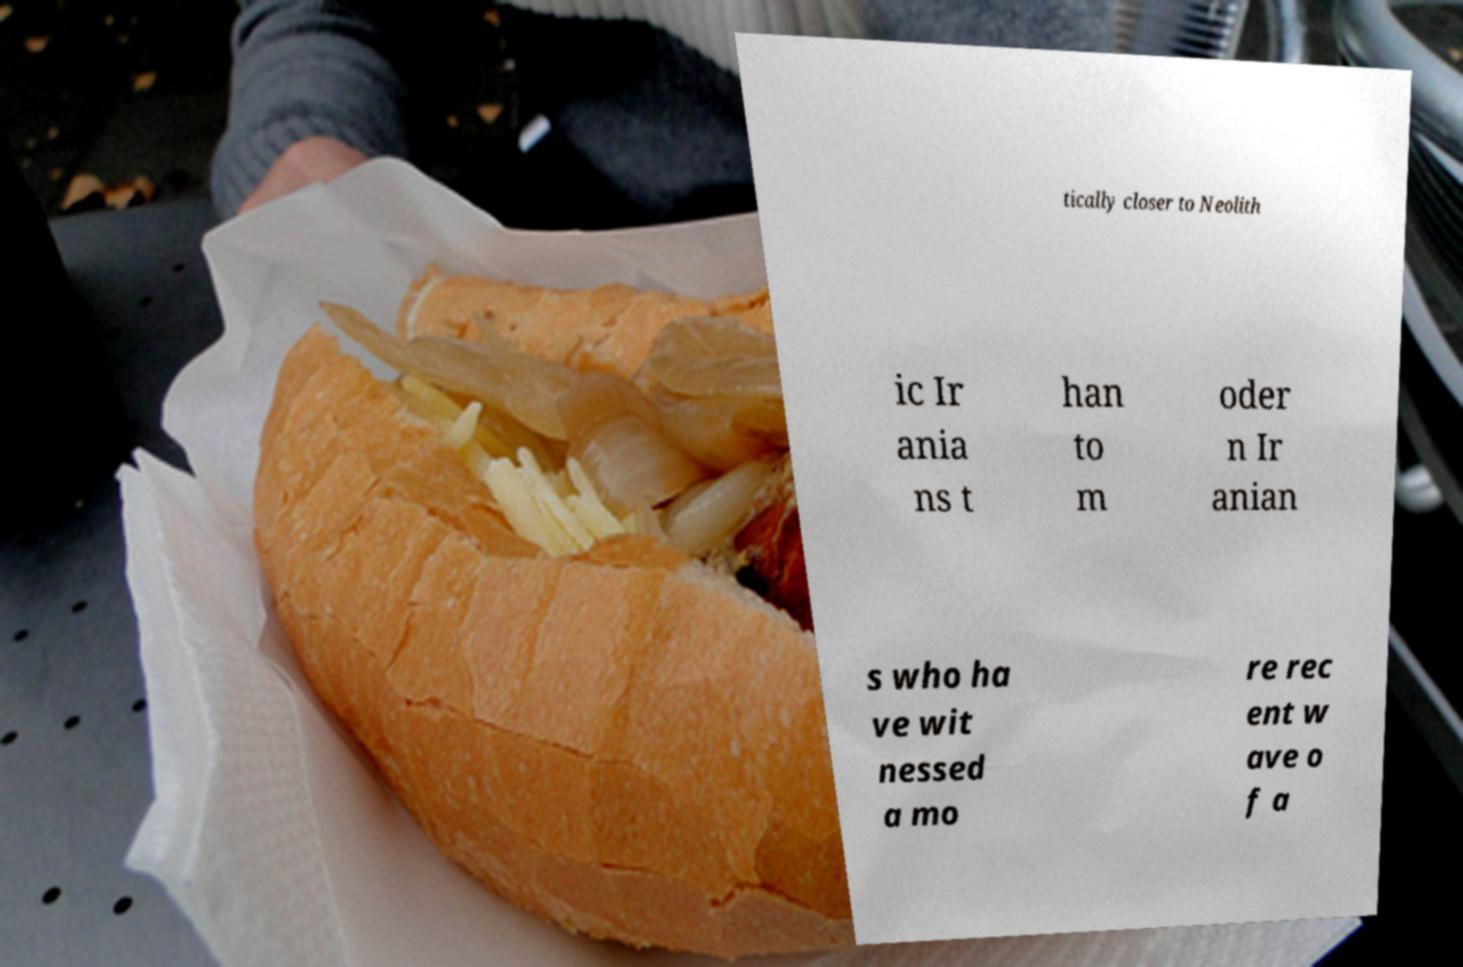Can you accurately transcribe the text from the provided image for me? tically closer to Neolith ic Ir ania ns t han to m oder n Ir anian s who ha ve wit nessed a mo re rec ent w ave o f a 